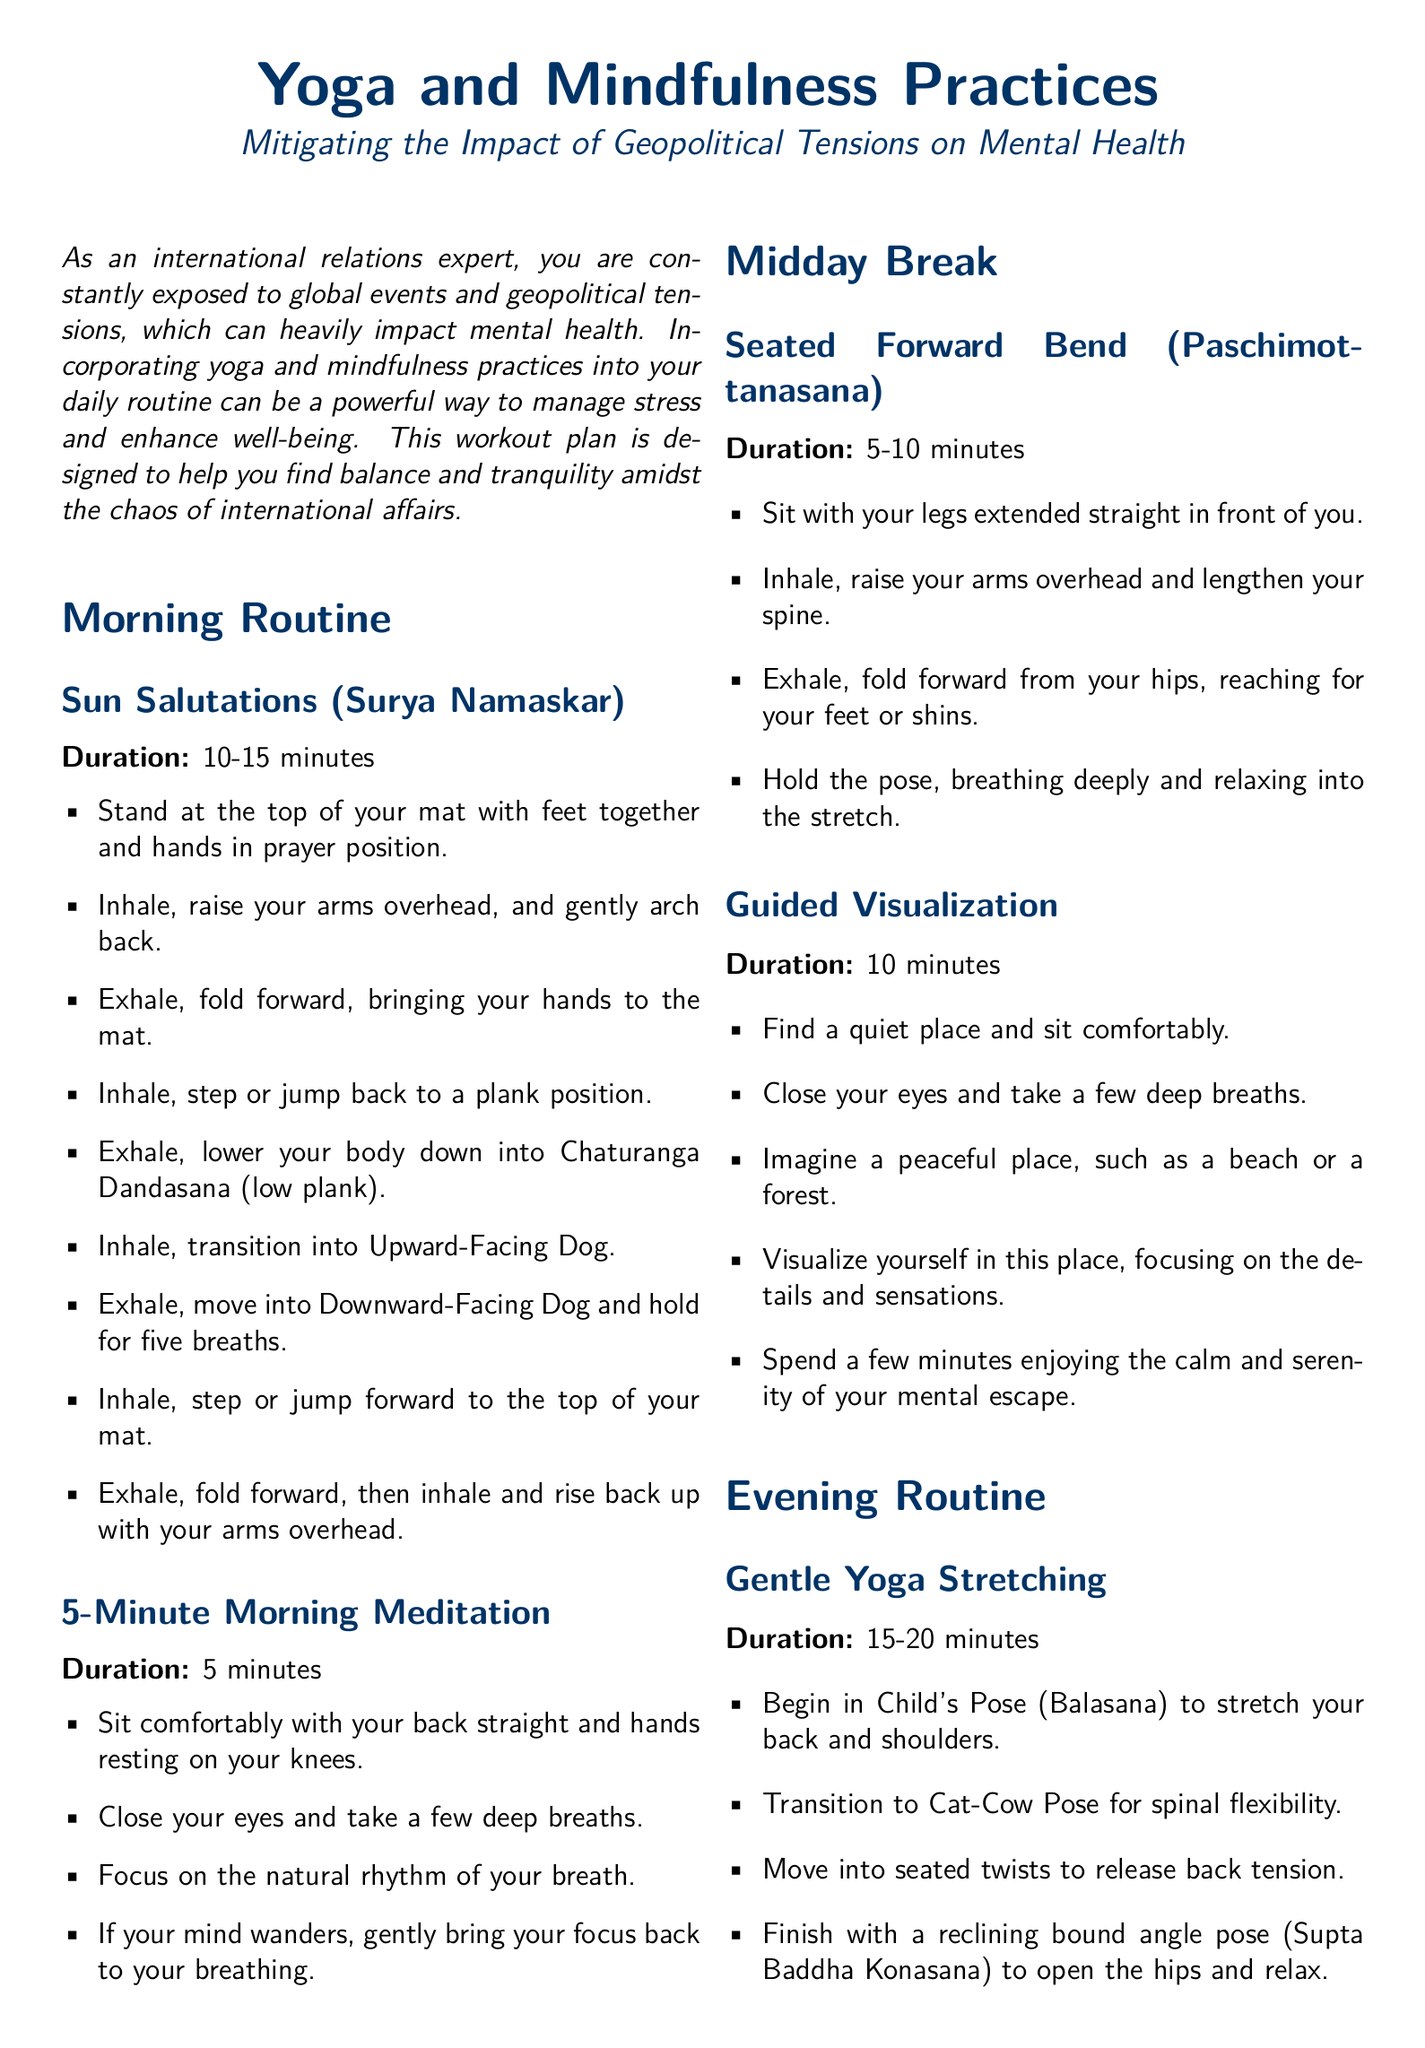What is the title of the document? The title of the document is found at the beginning, indicating its focus on yoga and mindfulness.
Answer: Yoga and Mindfulness Practices What is the duration of Sun Salutations? The document specifies a duration for the morning routine exercise, Sun Salutations.
Answer: 10-15 minutes What mindfulness practice is suggested for the midday break? The document lists a specific yoga pose and a mindfulness technique as part of the midday break.
Answer: Seated Forward Bend How long should the evening routine's body scan meditation last? The specified duration for the body scan meditation in the evening routine is noted in the document.
Answer: 10 minutes What is the first position you start with in the evening routine? The document details the poses in the evening routine, starting with one's initial position.
Answer: Child's Pose What kind of practice is recommended after the 5-minute morning meditation? The document outlines consecutive practices, highlighting what comes immediately after the morning meditation.
Answer: Seated Forward Bend How many exercises are listed in the morning routine? The document outlines several components in the morning routine, allowing a count of the exercises.
Answer: 2 exercises What visualization technique is recommended? The document describes a mental escape technique, focusing on where to visualize oneself.
Answer: Guided Visualization 